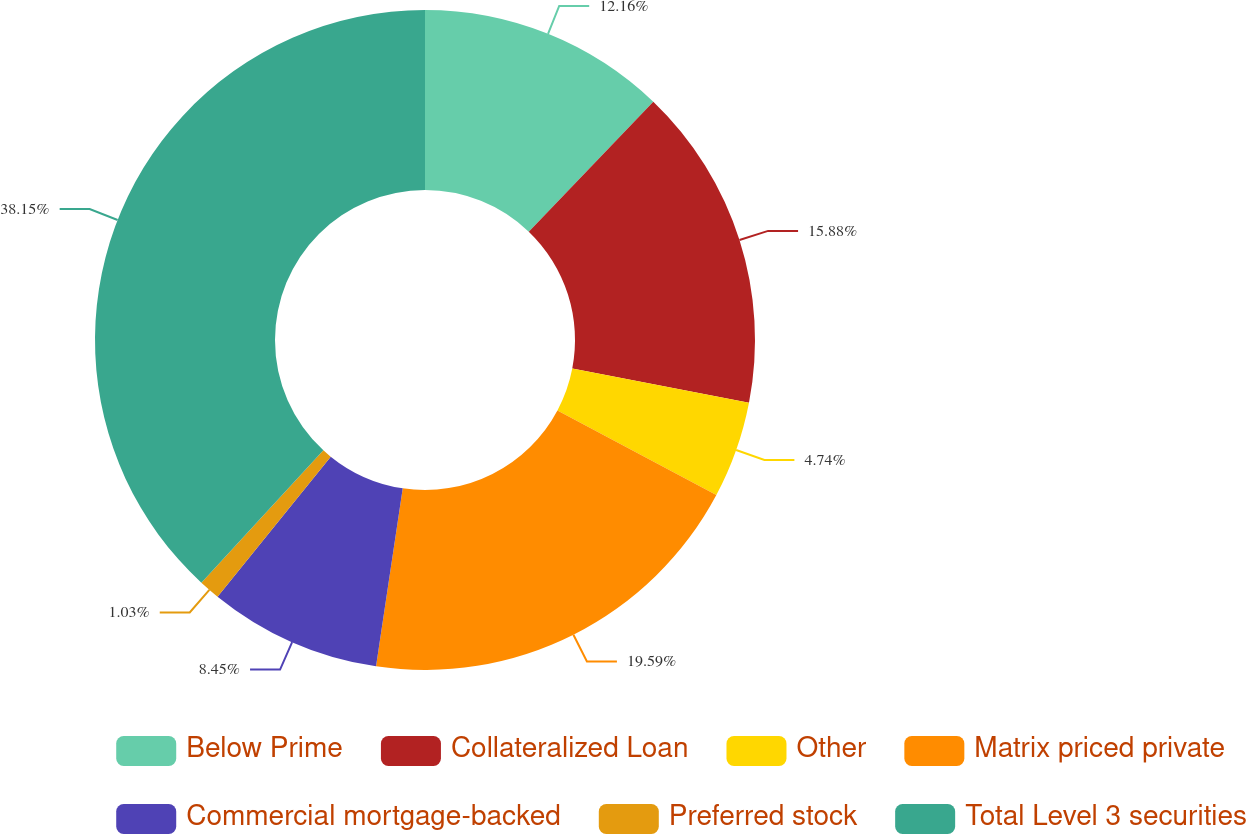Convert chart to OTSL. <chart><loc_0><loc_0><loc_500><loc_500><pie_chart><fcel>Below Prime<fcel>Collateralized Loan<fcel>Other<fcel>Matrix priced private<fcel>Commercial mortgage-backed<fcel>Preferred stock<fcel>Total Level 3 securities<nl><fcel>12.16%<fcel>15.88%<fcel>4.74%<fcel>19.59%<fcel>8.45%<fcel>1.03%<fcel>38.15%<nl></chart> 